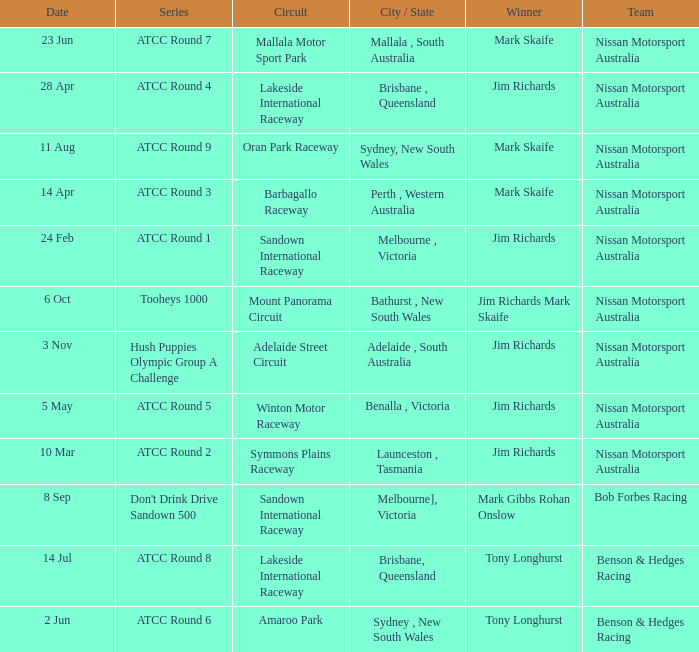What is the Circuit in the ATCC Round 1 Series with Winner Jim Richards? Sandown International Raceway. 